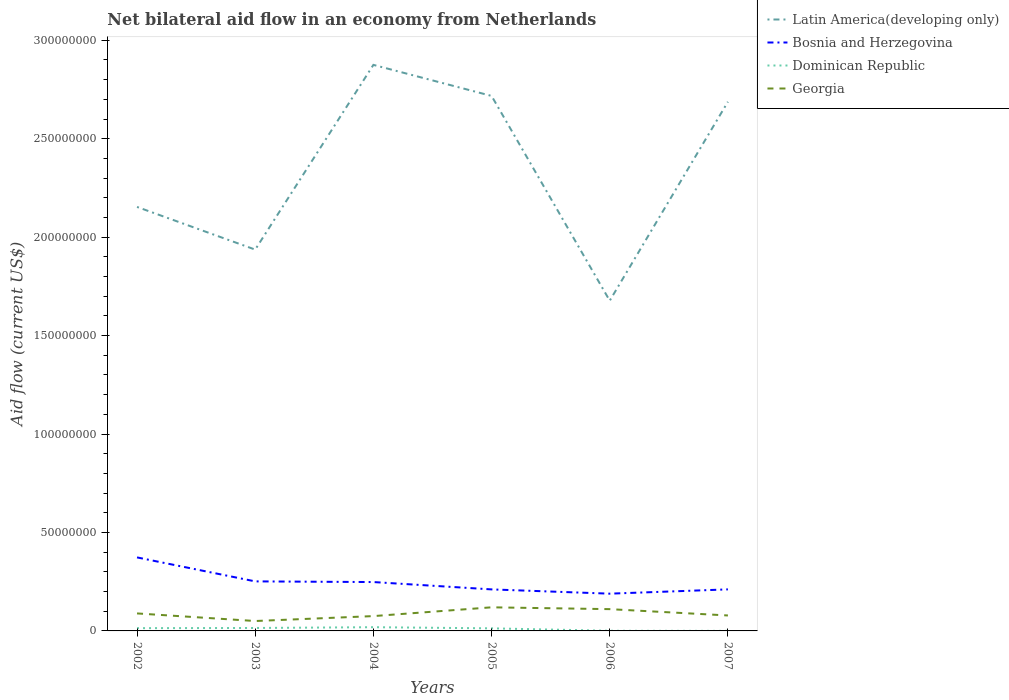Does the line corresponding to Latin America(developing only) intersect with the line corresponding to Bosnia and Herzegovina?
Your response must be concise. No. Is the number of lines equal to the number of legend labels?
Your response must be concise. Yes. Across all years, what is the maximum net bilateral aid flow in Bosnia and Herzegovina?
Offer a very short reply. 1.89e+07. In which year was the net bilateral aid flow in Dominican Republic maximum?
Keep it short and to the point. 2007. What is the total net bilateral aid flow in Georgia in the graph?
Keep it short and to the point. 1.04e+06. What is the difference between the highest and the second highest net bilateral aid flow in Georgia?
Provide a short and direct response. 6.96e+06. What is the difference between the highest and the lowest net bilateral aid flow in Georgia?
Provide a short and direct response. 3. Is the net bilateral aid flow in Bosnia and Herzegovina strictly greater than the net bilateral aid flow in Dominican Republic over the years?
Offer a very short reply. No. Does the graph contain grids?
Offer a terse response. No. How many legend labels are there?
Give a very brief answer. 4. What is the title of the graph?
Your response must be concise. Net bilateral aid flow in an economy from Netherlands. Does "Afghanistan" appear as one of the legend labels in the graph?
Offer a terse response. No. What is the label or title of the X-axis?
Keep it short and to the point. Years. What is the label or title of the Y-axis?
Provide a short and direct response. Aid flow (current US$). What is the Aid flow (current US$) in Latin America(developing only) in 2002?
Keep it short and to the point. 2.15e+08. What is the Aid flow (current US$) in Bosnia and Herzegovina in 2002?
Offer a terse response. 3.73e+07. What is the Aid flow (current US$) in Dominican Republic in 2002?
Your response must be concise. 1.41e+06. What is the Aid flow (current US$) in Georgia in 2002?
Your answer should be compact. 8.89e+06. What is the Aid flow (current US$) of Latin America(developing only) in 2003?
Provide a succinct answer. 1.94e+08. What is the Aid flow (current US$) in Bosnia and Herzegovina in 2003?
Keep it short and to the point. 2.52e+07. What is the Aid flow (current US$) in Dominican Republic in 2003?
Your answer should be compact. 1.49e+06. What is the Aid flow (current US$) in Georgia in 2003?
Ensure brevity in your answer.  5.03e+06. What is the Aid flow (current US$) of Latin America(developing only) in 2004?
Keep it short and to the point. 2.88e+08. What is the Aid flow (current US$) in Bosnia and Herzegovina in 2004?
Provide a succinct answer. 2.48e+07. What is the Aid flow (current US$) in Dominican Republic in 2004?
Keep it short and to the point. 1.89e+06. What is the Aid flow (current US$) in Georgia in 2004?
Keep it short and to the point. 7.53e+06. What is the Aid flow (current US$) of Latin America(developing only) in 2005?
Keep it short and to the point. 2.72e+08. What is the Aid flow (current US$) of Bosnia and Herzegovina in 2005?
Your answer should be compact. 2.11e+07. What is the Aid flow (current US$) in Dominican Republic in 2005?
Keep it short and to the point. 1.31e+06. What is the Aid flow (current US$) of Georgia in 2005?
Provide a short and direct response. 1.20e+07. What is the Aid flow (current US$) of Latin America(developing only) in 2006?
Your answer should be compact. 1.68e+08. What is the Aid flow (current US$) in Bosnia and Herzegovina in 2006?
Provide a short and direct response. 1.89e+07. What is the Aid flow (current US$) in Dominican Republic in 2006?
Your answer should be compact. 7.00e+04. What is the Aid flow (current US$) in Georgia in 2006?
Your answer should be very brief. 1.11e+07. What is the Aid flow (current US$) in Latin America(developing only) in 2007?
Your response must be concise. 2.69e+08. What is the Aid flow (current US$) in Bosnia and Herzegovina in 2007?
Your answer should be very brief. 2.11e+07. What is the Aid flow (current US$) of Georgia in 2007?
Offer a terse response. 7.85e+06. Across all years, what is the maximum Aid flow (current US$) of Latin America(developing only)?
Make the answer very short. 2.88e+08. Across all years, what is the maximum Aid flow (current US$) in Bosnia and Herzegovina?
Your response must be concise. 3.73e+07. Across all years, what is the maximum Aid flow (current US$) in Dominican Republic?
Your answer should be very brief. 1.89e+06. Across all years, what is the maximum Aid flow (current US$) of Georgia?
Your answer should be very brief. 1.20e+07. Across all years, what is the minimum Aid flow (current US$) of Latin America(developing only)?
Provide a short and direct response. 1.68e+08. Across all years, what is the minimum Aid flow (current US$) of Bosnia and Herzegovina?
Your response must be concise. 1.89e+07. Across all years, what is the minimum Aid flow (current US$) in Dominican Republic?
Keep it short and to the point. 2.00e+04. Across all years, what is the minimum Aid flow (current US$) of Georgia?
Keep it short and to the point. 5.03e+06. What is the total Aid flow (current US$) in Latin America(developing only) in the graph?
Your answer should be compact. 1.40e+09. What is the total Aid flow (current US$) of Bosnia and Herzegovina in the graph?
Ensure brevity in your answer.  1.48e+08. What is the total Aid flow (current US$) of Dominican Republic in the graph?
Your response must be concise. 6.19e+06. What is the total Aid flow (current US$) of Georgia in the graph?
Offer a terse response. 5.24e+07. What is the difference between the Aid flow (current US$) of Latin America(developing only) in 2002 and that in 2003?
Keep it short and to the point. 2.17e+07. What is the difference between the Aid flow (current US$) in Bosnia and Herzegovina in 2002 and that in 2003?
Make the answer very short. 1.22e+07. What is the difference between the Aid flow (current US$) of Dominican Republic in 2002 and that in 2003?
Provide a short and direct response. -8.00e+04. What is the difference between the Aid flow (current US$) in Georgia in 2002 and that in 2003?
Ensure brevity in your answer.  3.86e+06. What is the difference between the Aid flow (current US$) of Latin America(developing only) in 2002 and that in 2004?
Offer a very short reply. -7.22e+07. What is the difference between the Aid flow (current US$) of Bosnia and Herzegovina in 2002 and that in 2004?
Make the answer very short. 1.25e+07. What is the difference between the Aid flow (current US$) of Dominican Republic in 2002 and that in 2004?
Provide a short and direct response. -4.80e+05. What is the difference between the Aid flow (current US$) in Georgia in 2002 and that in 2004?
Your answer should be compact. 1.36e+06. What is the difference between the Aid flow (current US$) of Latin America(developing only) in 2002 and that in 2005?
Ensure brevity in your answer.  -5.64e+07. What is the difference between the Aid flow (current US$) in Bosnia and Herzegovina in 2002 and that in 2005?
Ensure brevity in your answer.  1.62e+07. What is the difference between the Aid flow (current US$) of Georgia in 2002 and that in 2005?
Your answer should be compact. -3.10e+06. What is the difference between the Aid flow (current US$) of Latin America(developing only) in 2002 and that in 2006?
Keep it short and to the point. 4.76e+07. What is the difference between the Aid flow (current US$) of Bosnia and Herzegovina in 2002 and that in 2006?
Offer a terse response. 1.84e+07. What is the difference between the Aid flow (current US$) of Dominican Republic in 2002 and that in 2006?
Give a very brief answer. 1.34e+06. What is the difference between the Aid flow (current US$) of Georgia in 2002 and that in 2006?
Provide a succinct answer. -2.17e+06. What is the difference between the Aid flow (current US$) in Latin America(developing only) in 2002 and that in 2007?
Offer a very short reply. -5.34e+07. What is the difference between the Aid flow (current US$) in Bosnia and Herzegovina in 2002 and that in 2007?
Ensure brevity in your answer.  1.62e+07. What is the difference between the Aid flow (current US$) of Dominican Republic in 2002 and that in 2007?
Give a very brief answer. 1.39e+06. What is the difference between the Aid flow (current US$) of Georgia in 2002 and that in 2007?
Ensure brevity in your answer.  1.04e+06. What is the difference between the Aid flow (current US$) of Latin America(developing only) in 2003 and that in 2004?
Keep it short and to the point. -9.38e+07. What is the difference between the Aid flow (current US$) of Bosnia and Herzegovina in 2003 and that in 2004?
Keep it short and to the point. 3.40e+05. What is the difference between the Aid flow (current US$) of Dominican Republic in 2003 and that in 2004?
Your answer should be very brief. -4.00e+05. What is the difference between the Aid flow (current US$) of Georgia in 2003 and that in 2004?
Provide a short and direct response. -2.50e+06. What is the difference between the Aid flow (current US$) in Latin America(developing only) in 2003 and that in 2005?
Your response must be concise. -7.80e+07. What is the difference between the Aid flow (current US$) of Bosnia and Herzegovina in 2003 and that in 2005?
Provide a short and direct response. 4.07e+06. What is the difference between the Aid flow (current US$) in Dominican Republic in 2003 and that in 2005?
Give a very brief answer. 1.80e+05. What is the difference between the Aid flow (current US$) in Georgia in 2003 and that in 2005?
Keep it short and to the point. -6.96e+06. What is the difference between the Aid flow (current US$) of Latin America(developing only) in 2003 and that in 2006?
Offer a terse response. 2.60e+07. What is the difference between the Aid flow (current US$) of Bosnia and Herzegovina in 2003 and that in 2006?
Offer a very short reply. 6.24e+06. What is the difference between the Aid flow (current US$) of Dominican Republic in 2003 and that in 2006?
Your answer should be very brief. 1.42e+06. What is the difference between the Aid flow (current US$) in Georgia in 2003 and that in 2006?
Ensure brevity in your answer.  -6.03e+06. What is the difference between the Aid flow (current US$) of Latin America(developing only) in 2003 and that in 2007?
Offer a terse response. -7.51e+07. What is the difference between the Aid flow (current US$) in Bosnia and Herzegovina in 2003 and that in 2007?
Your response must be concise. 4.06e+06. What is the difference between the Aid flow (current US$) in Dominican Republic in 2003 and that in 2007?
Keep it short and to the point. 1.47e+06. What is the difference between the Aid flow (current US$) of Georgia in 2003 and that in 2007?
Ensure brevity in your answer.  -2.82e+06. What is the difference between the Aid flow (current US$) of Latin America(developing only) in 2004 and that in 2005?
Offer a very short reply. 1.58e+07. What is the difference between the Aid flow (current US$) of Bosnia and Herzegovina in 2004 and that in 2005?
Make the answer very short. 3.73e+06. What is the difference between the Aid flow (current US$) of Dominican Republic in 2004 and that in 2005?
Offer a terse response. 5.80e+05. What is the difference between the Aid flow (current US$) of Georgia in 2004 and that in 2005?
Provide a short and direct response. -4.46e+06. What is the difference between the Aid flow (current US$) in Latin America(developing only) in 2004 and that in 2006?
Provide a short and direct response. 1.20e+08. What is the difference between the Aid flow (current US$) of Bosnia and Herzegovina in 2004 and that in 2006?
Your answer should be compact. 5.90e+06. What is the difference between the Aid flow (current US$) in Dominican Republic in 2004 and that in 2006?
Ensure brevity in your answer.  1.82e+06. What is the difference between the Aid flow (current US$) of Georgia in 2004 and that in 2006?
Your answer should be compact. -3.53e+06. What is the difference between the Aid flow (current US$) in Latin America(developing only) in 2004 and that in 2007?
Your answer should be very brief. 1.88e+07. What is the difference between the Aid flow (current US$) of Bosnia and Herzegovina in 2004 and that in 2007?
Keep it short and to the point. 3.72e+06. What is the difference between the Aid flow (current US$) in Dominican Republic in 2004 and that in 2007?
Make the answer very short. 1.87e+06. What is the difference between the Aid flow (current US$) in Georgia in 2004 and that in 2007?
Provide a succinct answer. -3.20e+05. What is the difference between the Aid flow (current US$) in Latin America(developing only) in 2005 and that in 2006?
Your response must be concise. 1.04e+08. What is the difference between the Aid flow (current US$) of Bosnia and Herzegovina in 2005 and that in 2006?
Keep it short and to the point. 2.17e+06. What is the difference between the Aid flow (current US$) in Dominican Republic in 2005 and that in 2006?
Keep it short and to the point. 1.24e+06. What is the difference between the Aid flow (current US$) of Georgia in 2005 and that in 2006?
Your answer should be very brief. 9.30e+05. What is the difference between the Aid flow (current US$) in Latin America(developing only) in 2005 and that in 2007?
Provide a succinct answer. 2.98e+06. What is the difference between the Aid flow (current US$) in Dominican Republic in 2005 and that in 2007?
Offer a terse response. 1.29e+06. What is the difference between the Aid flow (current US$) of Georgia in 2005 and that in 2007?
Ensure brevity in your answer.  4.14e+06. What is the difference between the Aid flow (current US$) in Latin America(developing only) in 2006 and that in 2007?
Offer a terse response. -1.01e+08. What is the difference between the Aid flow (current US$) in Bosnia and Herzegovina in 2006 and that in 2007?
Provide a short and direct response. -2.18e+06. What is the difference between the Aid flow (current US$) in Georgia in 2006 and that in 2007?
Offer a very short reply. 3.21e+06. What is the difference between the Aid flow (current US$) in Latin America(developing only) in 2002 and the Aid flow (current US$) in Bosnia and Herzegovina in 2003?
Your answer should be very brief. 1.90e+08. What is the difference between the Aid flow (current US$) of Latin America(developing only) in 2002 and the Aid flow (current US$) of Dominican Republic in 2003?
Provide a succinct answer. 2.14e+08. What is the difference between the Aid flow (current US$) in Latin America(developing only) in 2002 and the Aid flow (current US$) in Georgia in 2003?
Your answer should be very brief. 2.10e+08. What is the difference between the Aid flow (current US$) of Bosnia and Herzegovina in 2002 and the Aid flow (current US$) of Dominican Republic in 2003?
Keep it short and to the point. 3.58e+07. What is the difference between the Aid flow (current US$) of Bosnia and Herzegovina in 2002 and the Aid flow (current US$) of Georgia in 2003?
Make the answer very short. 3.23e+07. What is the difference between the Aid flow (current US$) in Dominican Republic in 2002 and the Aid flow (current US$) in Georgia in 2003?
Keep it short and to the point. -3.62e+06. What is the difference between the Aid flow (current US$) of Latin America(developing only) in 2002 and the Aid flow (current US$) of Bosnia and Herzegovina in 2004?
Your answer should be compact. 1.91e+08. What is the difference between the Aid flow (current US$) of Latin America(developing only) in 2002 and the Aid flow (current US$) of Dominican Republic in 2004?
Ensure brevity in your answer.  2.13e+08. What is the difference between the Aid flow (current US$) of Latin America(developing only) in 2002 and the Aid flow (current US$) of Georgia in 2004?
Ensure brevity in your answer.  2.08e+08. What is the difference between the Aid flow (current US$) in Bosnia and Herzegovina in 2002 and the Aid flow (current US$) in Dominican Republic in 2004?
Your answer should be very brief. 3.54e+07. What is the difference between the Aid flow (current US$) of Bosnia and Herzegovina in 2002 and the Aid flow (current US$) of Georgia in 2004?
Ensure brevity in your answer.  2.98e+07. What is the difference between the Aid flow (current US$) in Dominican Republic in 2002 and the Aid flow (current US$) in Georgia in 2004?
Offer a terse response. -6.12e+06. What is the difference between the Aid flow (current US$) of Latin America(developing only) in 2002 and the Aid flow (current US$) of Bosnia and Herzegovina in 2005?
Your response must be concise. 1.94e+08. What is the difference between the Aid flow (current US$) in Latin America(developing only) in 2002 and the Aid flow (current US$) in Dominican Republic in 2005?
Your answer should be compact. 2.14e+08. What is the difference between the Aid flow (current US$) of Latin America(developing only) in 2002 and the Aid flow (current US$) of Georgia in 2005?
Ensure brevity in your answer.  2.03e+08. What is the difference between the Aid flow (current US$) of Bosnia and Herzegovina in 2002 and the Aid flow (current US$) of Dominican Republic in 2005?
Give a very brief answer. 3.60e+07. What is the difference between the Aid flow (current US$) in Bosnia and Herzegovina in 2002 and the Aid flow (current US$) in Georgia in 2005?
Provide a short and direct response. 2.54e+07. What is the difference between the Aid flow (current US$) in Dominican Republic in 2002 and the Aid flow (current US$) in Georgia in 2005?
Offer a very short reply. -1.06e+07. What is the difference between the Aid flow (current US$) of Latin America(developing only) in 2002 and the Aid flow (current US$) of Bosnia and Herzegovina in 2006?
Provide a succinct answer. 1.96e+08. What is the difference between the Aid flow (current US$) in Latin America(developing only) in 2002 and the Aid flow (current US$) in Dominican Republic in 2006?
Your response must be concise. 2.15e+08. What is the difference between the Aid flow (current US$) of Latin America(developing only) in 2002 and the Aid flow (current US$) of Georgia in 2006?
Keep it short and to the point. 2.04e+08. What is the difference between the Aid flow (current US$) of Bosnia and Herzegovina in 2002 and the Aid flow (current US$) of Dominican Republic in 2006?
Provide a short and direct response. 3.73e+07. What is the difference between the Aid flow (current US$) of Bosnia and Herzegovina in 2002 and the Aid flow (current US$) of Georgia in 2006?
Your answer should be very brief. 2.63e+07. What is the difference between the Aid flow (current US$) of Dominican Republic in 2002 and the Aid flow (current US$) of Georgia in 2006?
Keep it short and to the point. -9.65e+06. What is the difference between the Aid flow (current US$) in Latin America(developing only) in 2002 and the Aid flow (current US$) in Bosnia and Herzegovina in 2007?
Your response must be concise. 1.94e+08. What is the difference between the Aid flow (current US$) in Latin America(developing only) in 2002 and the Aid flow (current US$) in Dominican Republic in 2007?
Make the answer very short. 2.15e+08. What is the difference between the Aid flow (current US$) in Latin America(developing only) in 2002 and the Aid flow (current US$) in Georgia in 2007?
Your response must be concise. 2.08e+08. What is the difference between the Aid flow (current US$) of Bosnia and Herzegovina in 2002 and the Aid flow (current US$) of Dominican Republic in 2007?
Provide a succinct answer. 3.73e+07. What is the difference between the Aid flow (current US$) of Bosnia and Herzegovina in 2002 and the Aid flow (current US$) of Georgia in 2007?
Keep it short and to the point. 2.95e+07. What is the difference between the Aid flow (current US$) in Dominican Republic in 2002 and the Aid flow (current US$) in Georgia in 2007?
Your answer should be very brief. -6.44e+06. What is the difference between the Aid flow (current US$) in Latin America(developing only) in 2003 and the Aid flow (current US$) in Bosnia and Herzegovina in 2004?
Offer a terse response. 1.69e+08. What is the difference between the Aid flow (current US$) in Latin America(developing only) in 2003 and the Aid flow (current US$) in Dominican Republic in 2004?
Provide a succinct answer. 1.92e+08. What is the difference between the Aid flow (current US$) in Latin America(developing only) in 2003 and the Aid flow (current US$) in Georgia in 2004?
Ensure brevity in your answer.  1.86e+08. What is the difference between the Aid flow (current US$) in Bosnia and Herzegovina in 2003 and the Aid flow (current US$) in Dominican Republic in 2004?
Give a very brief answer. 2.33e+07. What is the difference between the Aid flow (current US$) of Bosnia and Herzegovina in 2003 and the Aid flow (current US$) of Georgia in 2004?
Your answer should be very brief. 1.76e+07. What is the difference between the Aid flow (current US$) of Dominican Republic in 2003 and the Aid flow (current US$) of Georgia in 2004?
Ensure brevity in your answer.  -6.04e+06. What is the difference between the Aid flow (current US$) of Latin America(developing only) in 2003 and the Aid flow (current US$) of Bosnia and Herzegovina in 2005?
Offer a terse response. 1.73e+08. What is the difference between the Aid flow (current US$) of Latin America(developing only) in 2003 and the Aid flow (current US$) of Dominican Republic in 2005?
Provide a succinct answer. 1.92e+08. What is the difference between the Aid flow (current US$) of Latin America(developing only) in 2003 and the Aid flow (current US$) of Georgia in 2005?
Offer a terse response. 1.82e+08. What is the difference between the Aid flow (current US$) in Bosnia and Herzegovina in 2003 and the Aid flow (current US$) in Dominican Republic in 2005?
Make the answer very short. 2.38e+07. What is the difference between the Aid flow (current US$) of Bosnia and Herzegovina in 2003 and the Aid flow (current US$) of Georgia in 2005?
Give a very brief answer. 1.32e+07. What is the difference between the Aid flow (current US$) in Dominican Republic in 2003 and the Aid flow (current US$) in Georgia in 2005?
Make the answer very short. -1.05e+07. What is the difference between the Aid flow (current US$) in Latin America(developing only) in 2003 and the Aid flow (current US$) in Bosnia and Herzegovina in 2006?
Give a very brief answer. 1.75e+08. What is the difference between the Aid flow (current US$) of Latin America(developing only) in 2003 and the Aid flow (current US$) of Dominican Republic in 2006?
Your answer should be very brief. 1.94e+08. What is the difference between the Aid flow (current US$) of Latin America(developing only) in 2003 and the Aid flow (current US$) of Georgia in 2006?
Provide a short and direct response. 1.83e+08. What is the difference between the Aid flow (current US$) in Bosnia and Herzegovina in 2003 and the Aid flow (current US$) in Dominican Republic in 2006?
Your response must be concise. 2.51e+07. What is the difference between the Aid flow (current US$) in Bosnia and Herzegovina in 2003 and the Aid flow (current US$) in Georgia in 2006?
Provide a short and direct response. 1.41e+07. What is the difference between the Aid flow (current US$) in Dominican Republic in 2003 and the Aid flow (current US$) in Georgia in 2006?
Your answer should be compact. -9.57e+06. What is the difference between the Aid flow (current US$) of Latin America(developing only) in 2003 and the Aid flow (current US$) of Bosnia and Herzegovina in 2007?
Ensure brevity in your answer.  1.73e+08. What is the difference between the Aid flow (current US$) of Latin America(developing only) in 2003 and the Aid flow (current US$) of Dominican Republic in 2007?
Your answer should be very brief. 1.94e+08. What is the difference between the Aid flow (current US$) of Latin America(developing only) in 2003 and the Aid flow (current US$) of Georgia in 2007?
Provide a succinct answer. 1.86e+08. What is the difference between the Aid flow (current US$) of Bosnia and Herzegovina in 2003 and the Aid flow (current US$) of Dominican Republic in 2007?
Make the answer very short. 2.51e+07. What is the difference between the Aid flow (current US$) of Bosnia and Herzegovina in 2003 and the Aid flow (current US$) of Georgia in 2007?
Provide a short and direct response. 1.73e+07. What is the difference between the Aid flow (current US$) in Dominican Republic in 2003 and the Aid flow (current US$) in Georgia in 2007?
Keep it short and to the point. -6.36e+06. What is the difference between the Aid flow (current US$) in Latin America(developing only) in 2004 and the Aid flow (current US$) in Bosnia and Herzegovina in 2005?
Provide a succinct answer. 2.66e+08. What is the difference between the Aid flow (current US$) of Latin America(developing only) in 2004 and the Aid flow (current US$) of Dominican Republic in 2005?
Provide a succinct answer. 2.86e+08. What is the difference between the Aid flow (current US$) of Latin America(developing only) in 2004 and the Aid flow (current US$) of Georgia in 2005?
Your answer should be compact. 2.76e+08. What is the difference between the Aid flow (current US$) in Bosnia and Herzegovina in 2004 and the Aid flow (current US$) in Dominican Republic in 2005?
Provide a short and direct response. 2.35e+07. What is the difference between the Aid flow (current US$) of Bosnia and Herzegovina in 2004 and the Aid flow (current US$) of Georgia in 2005?
Ensure brevity in your answer.  1.28e+07. What is the difference between the Aid flow (current US$) of Dominican Republic in 2004 and the Aid flow (current US$) of Georgia in 2005?
Make the answer very short. -1.01e+07. What is the difference between the Aid flow (current US$) of Latin America(developing only) in 2004 and the Aid flow (current US$) of Bosnia and Herzegovina in 2006?
Offer a very short reply. 2.69e+08. What is the difference between the Aid flow (current US$) of Latin America(developing only) in 2004 and the Aid flow (current US$) of Dominican Republic in 2006?
Make the answer very short. 2.87e+08. What is the difference between the Aid flow (current US$) in Latin America(developing only) in 2004 and the Aid flow (current US$) in Georgia in 2006?
Provide a succinct answer. 2.76e+08. What is the difference between the Aid flow (current US$) of Bosnia and Herzegovina in 2004 and the Aid flow (current US$) of Dominican Republic in 2006?
Keep it short and to the point. 2.48e+07. What is the difference between the Aid flow (current US$) in Bosnia and Herzegovina in 2004 and the Aid flow (current US$) in Georgia in 2006?
Offer a terse response. 1.38e+07. What is the difference between the Aid flow (current US$) in Dominican Republic in 2004 and the Aid flow (current US$) in Georgia in 2006?
Ensure brevity in your answer.  -9.17e+06. What is the difference between the Aid flow (current US$) in Latin America(developing only) in 2004 and the Aid flow (current US$) in Bosnia and Herzegovina in 2007?
Keep it short and to the point. 2.66e+08. What is the difference between the Aid flow (current US$) of Latin America(developing only) in 2004 and the Aid flow (current US$) of Dominican Republic in 2007?
Provide a short and direct response. 2.87e+08. What is the difference between the Aid flow (current US$) of Latin America(developing only) in 2004 and the Aid flow (current US$) of Georgia in 2007?
Make the answer very short. 2.80e+08. What is the difference between the Aid flow (current US$) of Bosnia and Herzegovina in 2004 and the Aid flow (current US$) of Dominican Republic in 2007?
Provide a succinct answer. 2.48e+07. What is the difference between the Aid flow (current US$) of Bosnia and Herzegovina in 2004 and the Aid flow (current US$) of Georgia in 2007?
Give a very brief answer. 1.70e+07. What is the difference between the Aid flow (current US$) of Dominican Republic in 2004 and the Aid flow (current US$) of Georgia in 2007?
Offer a terse response. -5.96e+06. What is the difference between the Aid flow (current US$) in Latin America(developing only) in 2005 and the Aid flow (current US$) in Bosnia and Herzegovina in 2006?
Give a very brief answer. 2.53e+08. What is the difference between the Aid flow (current US$) of Latin America(developing only) in 2005 and the Aid flow (current US$) of Dominican Republic in 2006?
Provide a short and direct response. 2.72e+08. What is the difference between the Aid flow (current US$) in Latin America(developing only) in 2005 and the Aid flow (current US$) in Georgia in 2006?
Give a very brief answer. 2.61e+08. What is the difference between the Aid flow (current US$) of Bosnia and Herzegovina in 2005 and the Aid flow (current US$) of Dominican Republic in 2006?
Keep it short and to the point. 2.10e+07. What is the difference between the Aid flow (current US$) of Bosnia and Herzegovina in 2005 and the Aid flow (current US$) of Georgia in 2006?
Keep it short and to the point. 1.00e+07. What is the difference between the Aid flow (current US$) of Dominican Republic in 2005 and the Aid flow (current US$) of Georgia in 2006?
Offer a terse response. -9.75e+06. What is the difference between the Aid flow (current US$) of Latin America(developing only) in 2005 and the Aid flow (current US$) of Bosnia and Herzegovina in 2007?
Give a very brief answer. 2.51e+08. What is the difference between the Aid flow (current US$) in Latin America(developing only) in 2005 and the Aid flow (current US$) in Dominican Republic in 2007?
Provide a short and direct response. 2.72e+08. What is the difference between the Aid flow (current US$) in Latin America(developing only) in 2005 and the Aid flow (current US$) in Georgia in 2007?
Provide a short and direct response. 2.64e+08. What is the difference between the Aid flow (current US$) in Bosnia and Herzegovina in 2005 and the Aid flow (current US$) in Dominican Republic in 2007?
Ensure brevity in your answer.  2.11e+07. What is the difference between the Aid flow (current US$) in Bosnia and Herzegovina in 2005 and the Aid flow (current US$) in Georgia in 2007?
Offer a very short reply. 1.32e+07. What is the difference between the Aid flow (current US$) of Dominican Republic in 2005 and the Aid flow (current US$) of Georgia in 2007?
Provide a short and direct response. -6.54e+06. What is the difference between the Aid flow (current US$) in Latin America(developing only) in 2006 and the Aid flow (current US$) in Bosnia and Herzegovina in 2007?
Give a very brief answer. 1.47e+08. What is the difference between the Aid flow (current US$) in Latin America(developing only) in 2006 and the Aid flow (current US$) in Dominican Republic in 2007?
Offer a terse response. 1.68e+08. What is the difference between the Aid flow (current US$) of Latin America(developing only) in 2006 and the Aid flow (current US$) of Georgia in 2007?
Your answer should be compact. 1.60e+08. What is the difference between the Aid flow (current US$) of Bosnia and Herzegovina in 2006 and the Aid flow (current US$) of Dominican Republic in 2007?
Your answer should be compact. 1.89e+07. What is the difference between the Aid flow (current US$) of Bosnia and Herzegovina in 2006 and the Aid flow (current US$) of Georgia in 2007?
Your response must be concise. 1.11e+07. What is the difference between the Aid flow (current US$) of Dominican Republic in 2006 and the Aid flow (current US$) of Georgia in 2007?
Provide a short and direct response. -7.78e+06. What is the average Aid flow (current US$) in Latin America(developing only) per year?
Your answer should be very brief. 2.34e+08. What is the average Aid flow (current US$) in Bosnia and Herzegovina per year?
Ensure brevity in your answer.  2.47e+07. What is the average Aid flow (current US$) in Dominican Republic per year?
Provide a succinct answer. 1.03e+06. What is the average Aid flow (current US$) of Georgia per year?
Offer a terse response. 8.72e+06. In the year 2002, what is the difference between the Aid flow (current US$) in Latin America(developing only) and Aid flow (current US$) in Bosnia and Herzegovina?
Make the answer very short. 1.78e+08. In the year 2002, what is the difference between the Aid flow (current US$) in Latin America(developing only) and Aid flow (current US$) in Dominican Republic?
Provide a short and direct response. 2.14e+08. In the year 2002, what is the difference between the Aid flow (current US$) of Latin America(developing only) and Aid flow (current US$) of Georgia?
Offer a very short reply. 2.06e+08. In the year 2002, what is the difference between the Aid flow (current US$) in Bosnia and Herzegovina and Aid flow (current US$) in Dominican Republic?
Offer a terse response. 3.59e+07. In the year 2002, what is the difference between the Aid flow (current US$) in Bosnia and Herzegovina and Aid flow (current US$) in Georgia?
Offer a terse response. 2.84e+07. In the year 2002, what is the difference between the Aid flow (current US$) in Dominican Republic and Aid flow (current US$) in Georgia?
Offer a terse response. -7.48e+06. In the year 2003, what is the difference between the Aid flow (current US$) of Latin America(developing only) and Aid flow (current US$) of Bosnia and Herzegovina?
Make the answer very short. 1.69e+08. In the year 2003, what is the difference between the Aid flow (current US$) of Latin America(developing only) and Aid flow (current US$) of Dominican Republic?
Your answer should be very brief. 1.92e+08. In the year 2003, what is the difference between the Aid flow (current US$) of Latin America(developing only) and Aid flow (current US$) of Georgia?
Give a very brief answer. 1.89e+08. In the year 2003, what is the difference between the Aid flow (current US$) of Bosnia and Herzegovina and Aid flow (current US$) of Dominican Republic?
Keep it short and to the point. 2.37e+07. In the year 2003, what is the difference between the Aid flow (current US$) of Bosnia and Herzegovina and Aid flow (current US$) of Georgia?
Make the answer very short. 2.01e+07. In the year 2003, what is the difference between the Aid flow (current US$) of Dominican Republic and Aid flow (current US$) of Georgia?
Offer a terse response. -3.54e+06. In the year 2004, what is the difference between the Aid flow (current US$) in Latin America(developing only) and Aid flow (current US$) in Bosnia and Herzegovina?
Provide a short and direct response. 2.63e+08. In the year 2004, what is the difference between the Aid flow (current US$) of Latin America(developing only) and Aid flow (current US$) of Dominican Republic?
Ensure brevity in your answer.  2.86e+08. In the year 2004, what is the difference between the Aid flow (current US$) in Latin America(developing only) and Aid flow (current US$) in Georgia?
Your answer should be very brief. 2.80e+08. In the year 2004, what is the difference between the Aid flow (current US$) of Bosnia and Herzegovina and Aid flow (current US$) of Dominican Republic?
Ensure brevity in your answer.  2.29e+07. In the year 2004, what is the difference between the Aid flow (current US$) in Bosnia and Herzegovina and Aid flow (current US$) in Georgia?
Your answer should be very brief. 1.73e+07. In the year 2004, what is the difference between the Aid flow (current US$) of Dominican Republic and Aid flow (current US$) of Georgia?
Give a very brief answer. -5.64e+06. In the year 2005, what is the difference between the Aid flow (current US$) in Latin America(developing only) and Aid flow (current US$) in Bosnia and Herzegovina?
Provide a succinct answer. 2.51e+08. In the year 2005, what is the difference between the Aid flow (current US$) in Latin America(developing only) and Aid flow (current US$) in Dominican Republic?
Your answer should be very brief. 2.70e+08. In the year 2005, what is the difference between the Aid flow (current US$) of Latin America(developing only) and Aid flow (current US$) of Georgia?
Your response must be concise. 2.60e+08. In the year 2005, what is the difference between the Aid flow (current US$) in Bosnia and Herzegovina and Aid flow (current US$) in Dominican Republic?
Your answer should be very brief. 1.98e+07. In the year 2005, what is the difference between the Aid flow (current US$) of Bosnia and Herzegovina and Aid flow (current US$) of Georgia?
Your answer should be compact. 9.10e+06. In the year 2005, what is the difference between the Aid flow (current US$) of Dominican Republic and Aid flow (current US$) of Georgia?
Ensure brevity in your answer.  -1.07e+07. In the year 2006, what is the difference between the Aid flow (current US$) of Latin America(developing only) and Aid flow (current US$) of Bosnia and Herzegovina?
Give a very brief answer. 1.49e+08. In the year 2006, what is the difference between the Aid flow (current US$) of Latin America(developing only) and Aid flow (current US$) of Dominican Republic?
Your answer should be very brief. 1.68e+08. In the year 2006, what is the difference between the Aid flow (current US$) in Latin America(developing only) and Aid flow (current US$) in Georgia?
Provide a succinct answer. 1.57e+08. In the year 2006, what is the difference between the Aid flow (current US$) in Bosnia and Herzegovina and Aid flow (current US$) in Dominican Republic?
Give a very brief answer. 1.88e+07. In the year 2006, what is the difference between the Aid flow (current US$) in Bosnia and Herzegovina and Aid flow (current US$) in Georgia?
Provide a short and direct response. 7.86e+06. In the year 2006, what is the difference between the Aid flow (current US$) in Dominican Republic and Aid flow (current US$) in Georgia?
Provide a short and direct response. -1.10e+07. In the year 2007, what is the difference between the Aid flow (current US$) in Latin America(developing only) and Aid flow (current US$) in Bosnia and Herzegovina?
Offer a terse response. 2.48e+08. In the year 2007, what is the difference between the Aid flow (current US$) in Latin America(developing only) and Aid flow (current US$) in Dominican Republic?
Ensure brevity in your answer.  2.69e+08. In the year 2007, what is the difference between the Aid flow (current US$) in Latin America(developing only) and Aid flow (current US$) in Georgia?
Provide a succinct answer. 2.61e+08. In the year 2007, what is the difference between the Aid flow (current US$) of Bosnia and Herzegovina and Aid flow (current US$) of Dominican Republic?
Provide a succinct answer. 2.11e+07. In the year 2007, what is the difference between the Aid flow (current US$) in Bosnia and Herzegovina and Aid flow (current US$) in Georgia?
Keep it short and to the point. 1.32e+07. In the year 2007, what is the difference between the Aid flow (current US$) of Dominican Republic and Aid flow (current US$) of Georgia?
Your answer should be compact. -7.83e+06. What is the ratio of the Aid flow (current US$) of Latin America(developing only) in 2002 to that in 2003?
Provide a short and direct response. 1.11. What is the ratio of the Aid flow (current US$) of Bosnia and Herzegovina in 2002 to that in 2003?
Offer a very short reply. 1.48. What is the ratio of the Aid flow (current US$) of Dominican Republic in 2002 to that in 2003?
Offer a terse response. 0.95. What is the ratio of the Aid flow (current US$) of Georgia in 2002 to that in 2003?
Your answer should be very brief. 1.77. What is the ratio of the Aid flow (current US$) of Latin America(developing only) in 2002 to that in 2004?
Make the answer very short. 0.75. What is the ratio of the Aid flow (current US$) in Bosnia and Herzegovina in 2002 to that in 2004?
Offer a very short reply. 1.5. What is the ratio of the Aid flow (current US$) in Dominican Republic in 2002 to that in 2004?
Ensure brevity in your answer.  0.75. What is the ratio of the Aid flow (current US$) in Georgia in 2002 to that in 2004?
Make the answer very short. 1.18. What is the ratio of the Aid flow (current US$) in Latin America(developing only) in 2002 to that in 2005?
Give a very brief answer. 0.79. What is the ratio of the Aid flow (current US$) in Bosnia and Herzegovina in 2002 to that in 2005?
Provide a short and direct response. 1.77. What is the ratio of the Aid flow (current US$) of Dominican Republic in 2002 to that in 2005?
Provide a short and direct response. 1.08. What is the ratio of the Aid flow (current US$) of Georgia in 2002 to that in 2005?
Give a very brief answer. 0.74. What is the ratio of the Aid flow (current US$) of Latin America(developing only) in 2002 to that in 2006?
Your response must be concise. 1.28. What is the ratio of the Aid flow (current US$) in Bosnia and Herzegovina in 2002 to that in 2006?
Provide a succinct answer. 1.97. What is the ratio of the Aid flow (current US$) in Dominican Republic in 2002 to that in 2006?
Provide a succinct answer. 20.14. What is the ratio of the Aid flow (current US$) of Georgia in 2002 to that in 2006?
Keep it short and to the point. 0.8. What is the ratio of the Aid flow (current US$) in Latin America(developing only) in 2002 to that in 2007?
Ensure brevity in your answer.  0.8. What is the ratio of the Aid flow (current US$) of Bosnia and Herzegovina in 2002 to that in 2007?
Keep it short and to the point. 1.77. What is the ratio of the Aid flow (current US$) of Dominican Republic in 2002 to that in 2007?
Your response must be concise. 70.5. What is the ratio of the Aid flow (current US$) of Georgia in 2002 to that in 2007?
Give a very brief answer. 1.13. What is the ratio of the Aid flow (current US$) in Latin America(developing only) in 2003 to that in 2004?
Give a very brief answer. 0.67. What is the ratio of the Aid flow (current US$) of Bosnia and Herzegovina in 2003 to that in 2004?
Your answer should be compact. 1.01. What is the ratio of the Aid flow (current US$) in Dominican Republic in 2003 to that in 2004?
Your answer should be compact. 0.79. What is the ratio of the Aid flow (current US$) of Georgia in 2003 to that in 2004?
Offer a terse response. 0.67. What is the ratio of the Aid flow (current US$) of Latin America(developing only) in 2003 to that in 2005?
Make the answer very short. 0.71. What is the ratio of the Aid flow (current US$) in Bosnia and Herzegovina in 2003 to that in 2005?
Make the answer very short. 1.19. What is the ratio of the Aid flow (current US$) in Dominican Republic in 2003 to that in 2005?
Keep it short and to the point. 1.14. What is the ratio of the Aid flow (current US$) in Georgia in 2003 to that in 2005?
Make the answer very short. 0.42. What is the ratio of the Aid flow (current US$) in Latin America(developing only) in 2003 to that in 2006?
Your answer should be compact. 1.15. What is the ratio of the Aid flow (current US$) of Bosnia and Herzegovina in 2003 to that in 2006?
Offer a terse response. 1.33. What is the ratio of the Aid flow (current US$) in Dominican Republic in 2003 to that in 2006?
Give a very brief answer. 21.29. What is the ratio of the Aid flow (current US$) in Georgia in 2003 to that in 2006?
Make the answer very short. 0.45. What is the ratio of the Aid flow (current US$) of Latin America(developing only) in 2003 to that in 2007?
Your answer should be compact. 0.72. What is the ratio of the Aid flow (current US$) in Bosnia and Herzegovina in 2003 to that in 2007?
Offer a very short reply. 1.19. What is the ratio of the Aid flow (current US$) in Dominican Republic in 2003 to that in 2007?
Your answer should be compact. 74.5. What is the ratio of the Aid flow (current US$) in Georgia in 2003 to that in 2007?
Offer a terse response. 0.64. What is the ratio of the Aid flow (current US$) of Latin America(developing only) in 2004 to that in 2005?
Keep it short and to the point. 1.06. What is the ratio of the Aid flow (current US$) of Bosnia and Herzegovina in 2004 to that in 2005?
Your response must be concise. 1.18. What is the ratio of the Aid flow (current US$) of Dominican Republic in 2004 to that in 2005?
Give a very brief answer. 1.44. What is the ratio of the Aid flow (current US$) in Georgia in 2004 to that in 2005?
Offer a terse response. 0.63. What is the ratio of the Aid flow (current US$) in Latin America(developing only) in 2004 to that in 2006?
Provide a short and direct response. 1.71. What is the ratio of the Aid flow (current US$) in Bosnia and Herzegovina in 2004 to that in 2006?
Provide a short and direct response. 1.31. What is the ratio of the Aid flow (current US$) in Dominican Republic in 2004 to that in 2006?
Your answer should be very brief. 27. What is the ratio of the Aid flow (current US$) in Georgia in 2004 to that in 2006?
Offer a very short reply. 0.68. What is the ratio of the Aid flow (current US$) in Latin America(developing only) in 2004 to that in 2007?
Offer a very short reply. 1.07. What is the ratio of the Aid flow (current US$) of Bosnia and Herzegovina in 2004 to that in 2007?
Your response must be concise. 1.18. What is the ratio of the Aid flow (current US$) of Dominican Republic in 2004 to that in 2007?
Offer a very short reply. 94.5. What is the ratio of the Aid flow (current US$) in Georgia in 2004 to that in 2007?
Provide a short and direct response. 0.96. What is the ratio of the Aid flow (current US$) in Latin America(developing only) in 2005 to that in 2006?
Provide a succinct answer. 1.62. What is the ratio of the Aid flow (current US$) in Bosnia and Herzegovina in 2005 to that in 2006?
Your response must be concise. 1.11. What is the ratio of the Aid flow (current US$) in Dominican Republic in 2005 to that in 2006?
Offer a very short reply. 18.71. What is the ratio of the Aid flow (current US$) of Georgia in 2005 to that in 2006?
Offer a very short reply. 1.08. What is the ratio of the Aid flow (current US$) of Latin America(developing only) in 2005 to that in 2007?
Ensure brevity in your answer.  1.01. What is the ratio of the Aid flow (current US$) in Bosnia and Herzegovina in 2005 to that in 2007?
Offer a very short reply. 1. What is the ratio of the Aid flow (current US$) of Dominican Republic in 2005 to that in 2007?
Your response must be concise. 65.5. What is the ratio of the Aid flow (current US$) of Georgia in 2005 to that in 2007?
Provide a short and direct response. 1.53. What is the ratio of the Aid flow (current US$) of Latin America(developing only) in 2006 to that in 2007?
Your answer should be compact. 0.62. What is the ratio of the Aid flow (current US$) of Bosnia and Herzegovina in 2006 to that in 2007?
Your answer should be compact. 0.9. What is the ratio of the Aid flow (current US$) of Dominican Republic in 2006 to that in 2007?
Provide a short and direct response. 3.5. What is the ratio of the Aid flow (current US$) of Georgia in 2006 to that in 2007?
Your answer should be very brief. 1.41. What is the difference between the highest and the second highest Aid flow (current US$) in Latin America(developing only)?
Make the answer very short. 1.58e+07. What is the difference between the highest and the second highest Aid flow (current US$) in Bosnia and Herzegovina?
Ensure brevity in your answer.  1.22e+07. What is the difference between the highest and the second highest Aid flow (current US$) of Dominican Republic?
Your answer should be very brief. 4.00e+05. What is the difference between the highest and the second highest Aid flow (current US$) of Georgia?
Offer a terse response. 9.30e+05. What is the difference between the highest and the lowest Aid flow (current US$) in Latin America(developing only)?
Keep it short and to the point. 1.20e+08. What is the difference between the highest and the lowest Aid flow (current US$) of Bosnia and Herzegovina?
Give a very brief answer. 1.84e+07. What is the difference between the highest and the lowest Aid flow (current US$) in Dominican Republic?
Offer a very short reply. 1.87e+06. What is the difference between the highest and the lowest Aid flow (current US$) of Georgia?
Keep it short and to the point. 6.96e+06. 